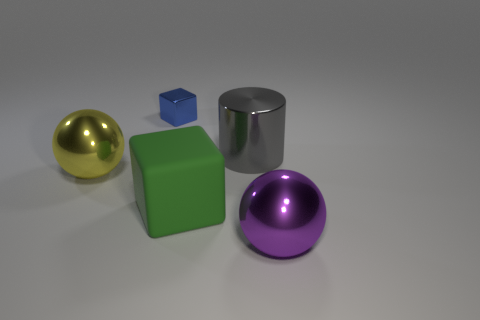Are any two objects identical in shape and size? There are no two objects in the image that are identical in both shape and size. Each object has a unique size or shape, ranging from spherical to cubic, which differentiates them from one another. 